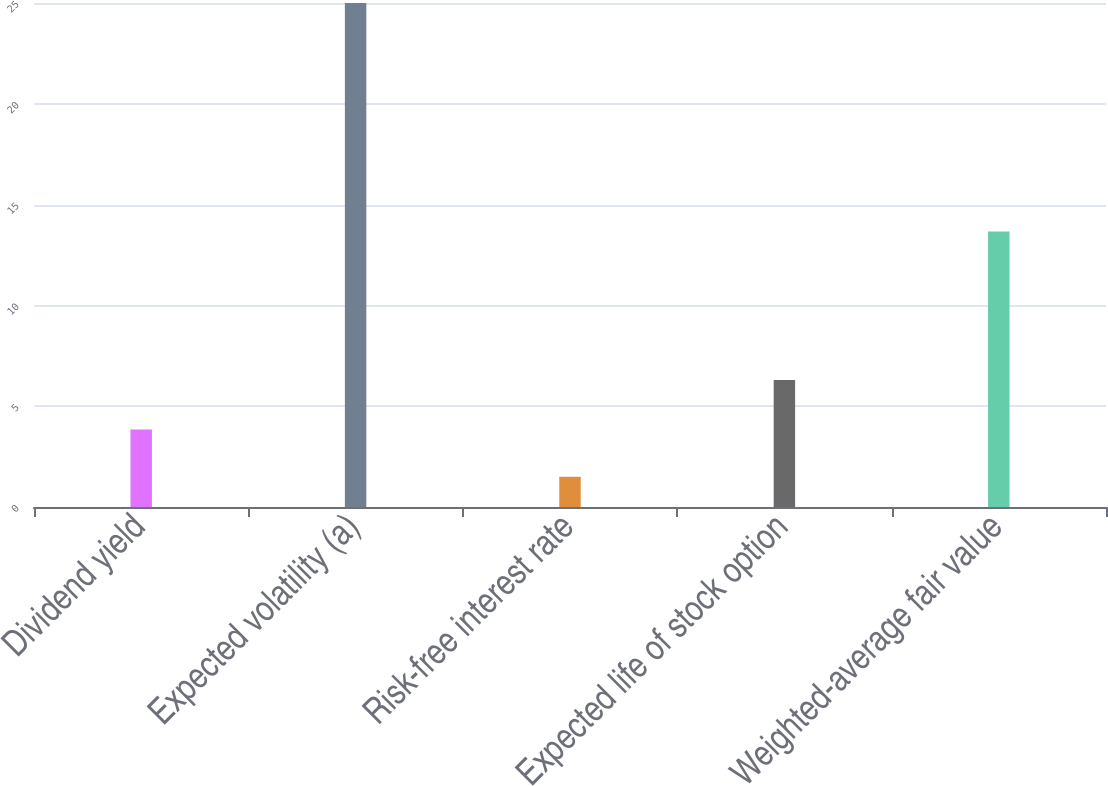<chart> <loc_0><loc_0><loc_500><loc_500><bar_chart><fcel>Dividend yield<fcel>Expected volatility (a)<fcel>Risk-free interest rate<fcel>Expected life of stock option<fcel>Weighted-average fair value<nl><fcel>3.85<fcel>25<fcel>1.5<fcel>6.3<fcel>13.67<nl></chart> 